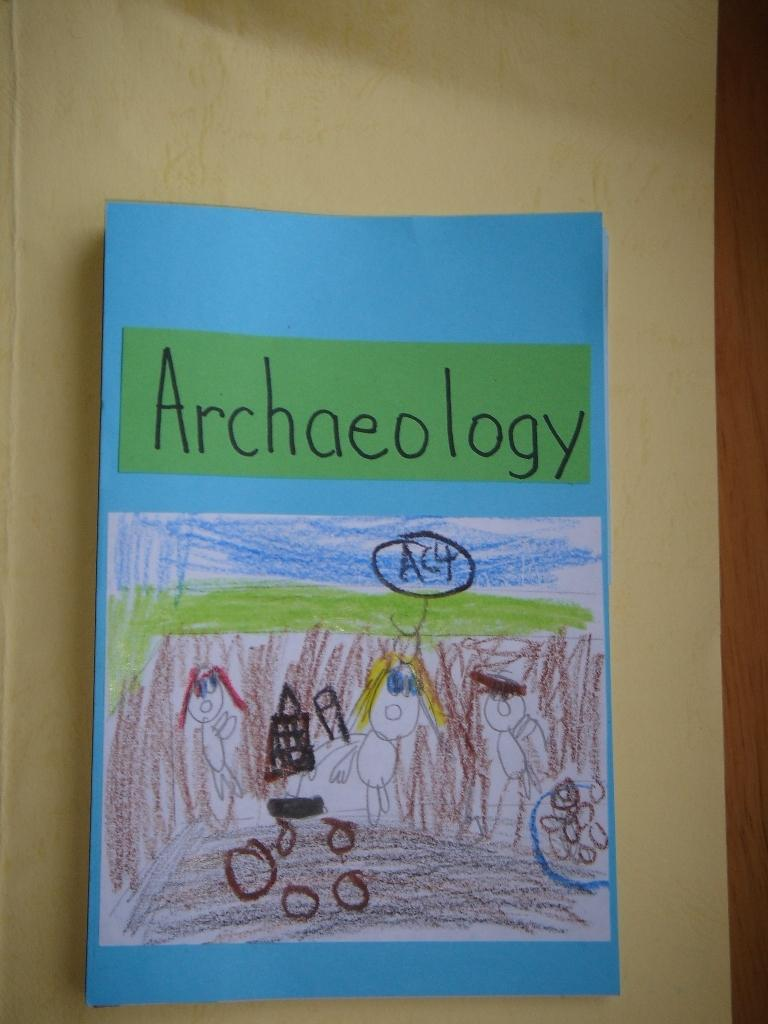<image>
Relay a brief, clear account of the picture shown. A child's school report covers the topic of Archaeology. 